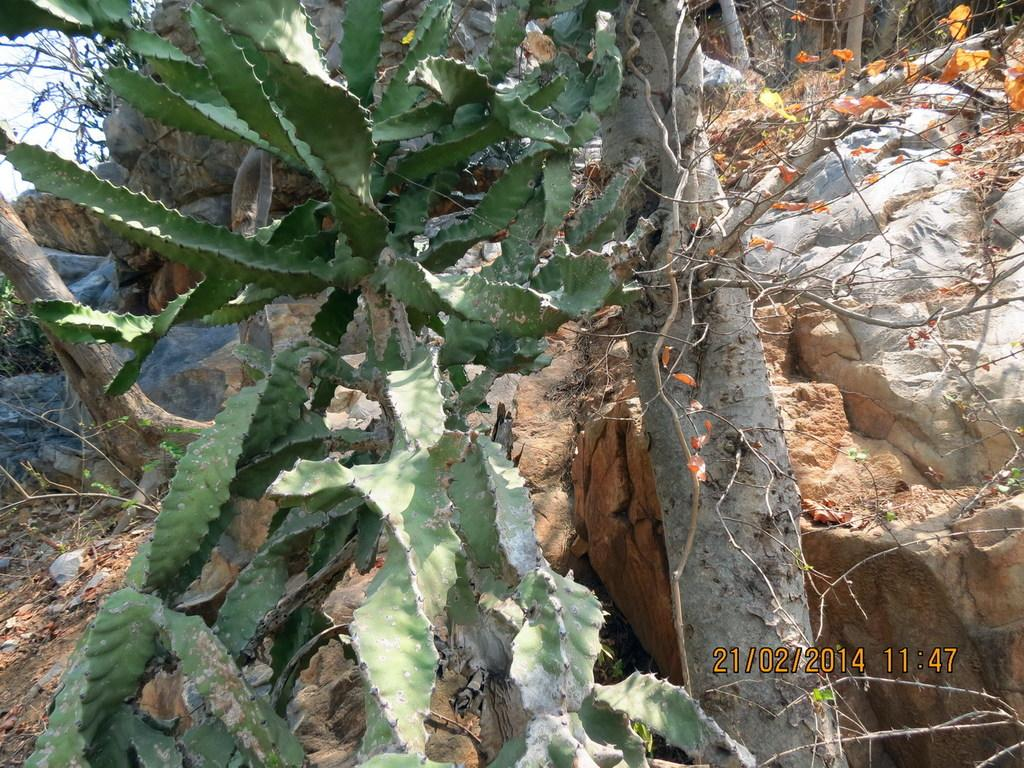What type of vegetation can be seen in the picture? There is a plant in the picture. What can be seen in the background of the picture? There are trees and rocks in the background of the picture. Where is the text or writing located in the image? The text or writing is in the right bottom corner of the image. Can you see a boat in the picture? No, there is no boat present in the image. What type of bread is being used as a prop in the picture? There is no bread present in the image. 